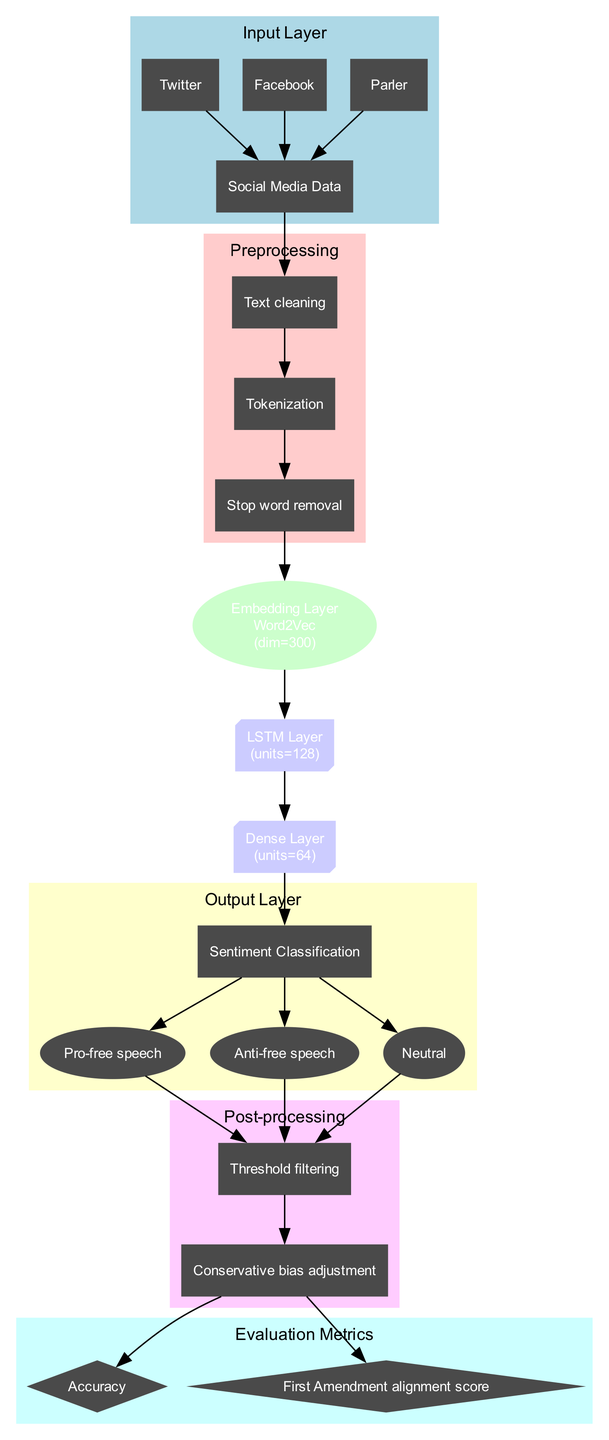What is the input data source? The input data source is listed in the input layer. According to the diagram, it includes "Twitter," "Facebook," and "Parler," which are the sources from which social media data is gathered.
Answer: Social Media Data How many preprocessing steps are there? The diagram details that there are three preprocessing steps: "Text cleaning," "Tokenization," and "Stop word removal." These steps can be counted to determine the total, which is three.
Answer: 3 What type of embedding layer is used? The type of embedding layer is specified in the diagram, which indicates that a "Word2Vec" embedding is being utilized in this neural network architecture for sentiment analysis.
Answer: Word2Vec How many units are in the LSTM layer? The diagram clearly states that the LSTM layer contains 128 units, which can be seen by inspecting the hidden layers section of the diagram.
Answer: 128 Which class corresponds to a neutral sentiment? The output layer lists three classes for sentiment classification, one of which is "Neutral." This indicates that the classification process includes a neutral sentiment category.
Answer: Neutral What are the evaluation metrics used? The evaluation metrics are mentioned in the evaluation metrics section and include "Accuracy" and "First Amendment alignment score." These two metrics assess the performance of the neural network.
Answer: Accuracy, First Amendment alignment score What is the purpose of the Conservative bias adjustment step? In the post-processing section, the "Conservative bias adjustment" is mentioned, indicating it is designed to tailor the output further to align with conservative viewpoints, especially in the context of free speech.
Answer: Conservative bias adjustment What follows the Dense Layer? According to the flow of the diagram, after the Dense layer, the next step leads directly to the output layer, where sentiment classification occurs.
Answer: Output Layer 